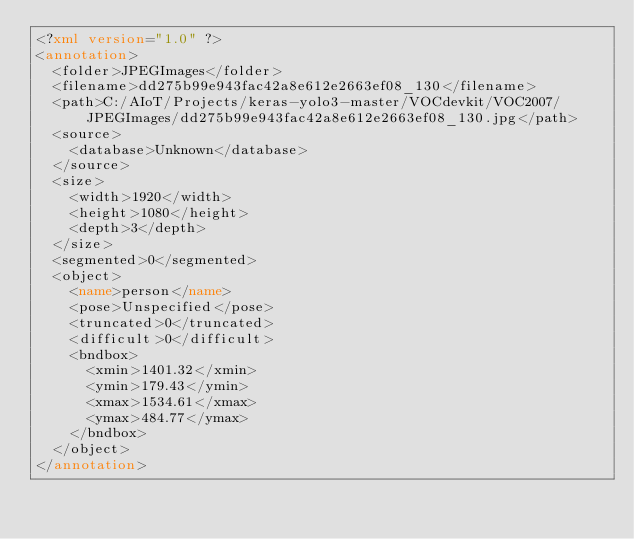<code> <loc_0><loc_0><loc_500><loc_500><_XML_><?xml version="1.0" ?>
<annotation>
	<folder>JPEGImages</folder>
	<filename>dd275b99e943fac42a8e612e2663ef08_130</filename>
	<path>C:/AIoT/Projects/keras-yolo3-master/VOCdevkit/VOC2007/JPEGImages/dd275b99e943fac42a8e612e2663ef08_130.jpg</path>
	<source>
		<database>Unknown</database>
	</source>
	<size>
		<width>1920</width>
		<height>1080</height>
		<depth>3</depth>
	</size>
	<segmented>0</segmented>
	<object>
		<name>person</name>
		<pose>Unspecified</pose>
		<truncated>0</truncated>
		<difficult>0</difficult>
		<bndbox>
			<xmin>1401.32</xmin>
			<ymin>179.43</ymin>
			<xmax>1534.61</xmax>
			<ymax>484.77</ymax>
		</bndbox>
	</object>
</annotation>
</code> 